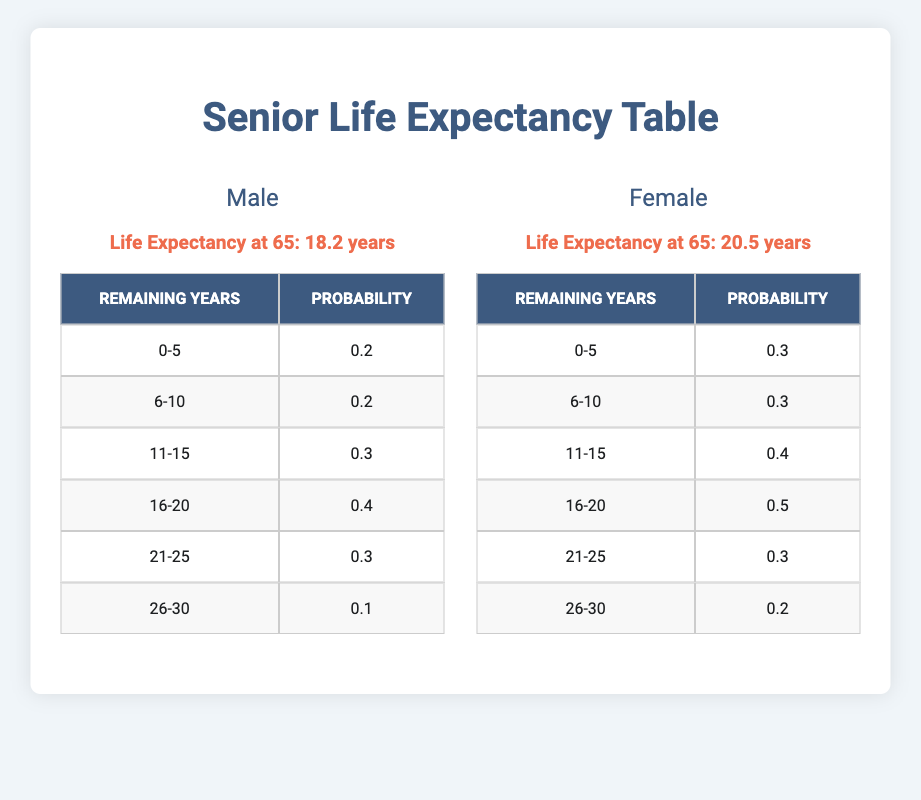What is the life expectancy at age 65 for males? The table displays the life expectancy for males at age 65 as 18.2 years.
Answer: 18.2 years What is the probability of living 6-10 more years for females? The table shows that the probability of females living an additional 6-10 years is 0.3.
Answer: 0.3 Is the life expectancy for females at age 65 greater than 19 years? By looking at the table, the life expectancy for females is 20.5 years, which confirms it is greater than 19 years.
Answer: Yes What is the total probability of males living between 0-15 years? To find the total probability, we add the probabilities for 0-5 years (0.2), 6-10 years (0.2), and 11-15 years (0.3): 0.2 + 0.2 + 0.3 = 0.7.
Answer: 0.7 What is the average remaining years that females expect to live from age 65? To find the average remaining years for females, we calculate the sum of years weighted by their probabilities: (0.3*2.5 + 0.3*8 + 0.4*13 + 0.5*18 + 0.3*23 + 0.2*28) = 7.5 + 2.4 + 5.2 + 9.0 + 6.9 + 5.6 = 36.6; then divide by total weights: 36.6 / (0.3 + 0.3 + 0.4 + 0.5 + 0.3 + 0.2) = 36.6 / 2.0 = 18.3, so the average is 18.3 years.
Answer: 18.3 years 